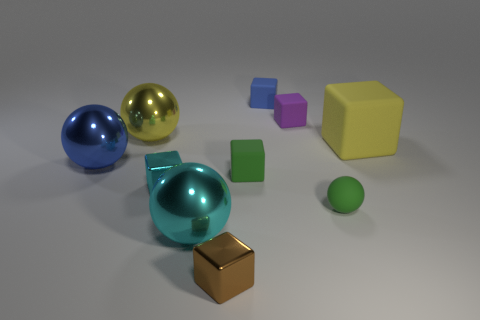Subtract all large yellow balls. How many balls are left? 3 Subtract 1 cubes. How many cubes are left? 5 Subtract all blue cubes. How many cubes are left? 5 Subtract all tiny red matte spheres. Subtract all small metal blocks. How many objects are left? 8 Add 5 cyan metallic cubes. How many cyan metallic cubes are left? 6 Add 6 big blocks. How many big blocks exist? 7 Subtract 0 red blocks. How many objects are left? 10 Subtract all cubes. How many objects are left? 4 Subtract all blue blocks. Subtract all cyan cylinders. How many blocks are left? 5 Subtract all red spheres. How many purple cubes are left? 1 